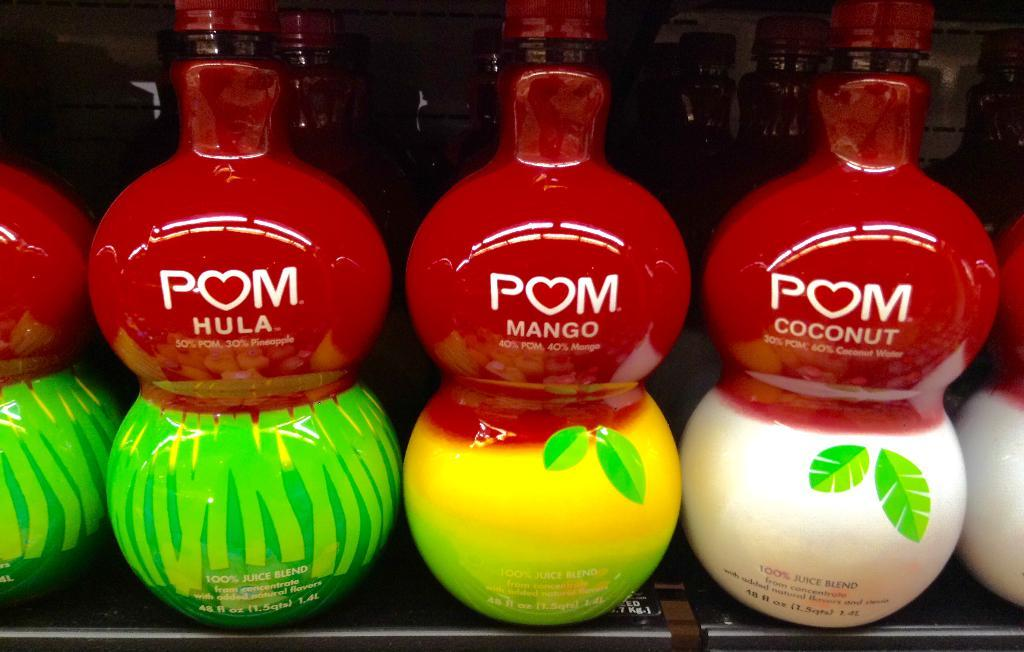How many bottles can be seen in the front side of the image? There are four bottles in the front side of the image. What is the distribution of bottles in the image? There are many bottles in the back side of the image, and there is a bottle in the middle of the image with text on it. Can you describe the bottle in the middle of the image? Yes, there is a bottle in the middle of the image with text on it. What type of rose is the queen holding in the image? There is no queen or rose present in the image; it features bottles. 